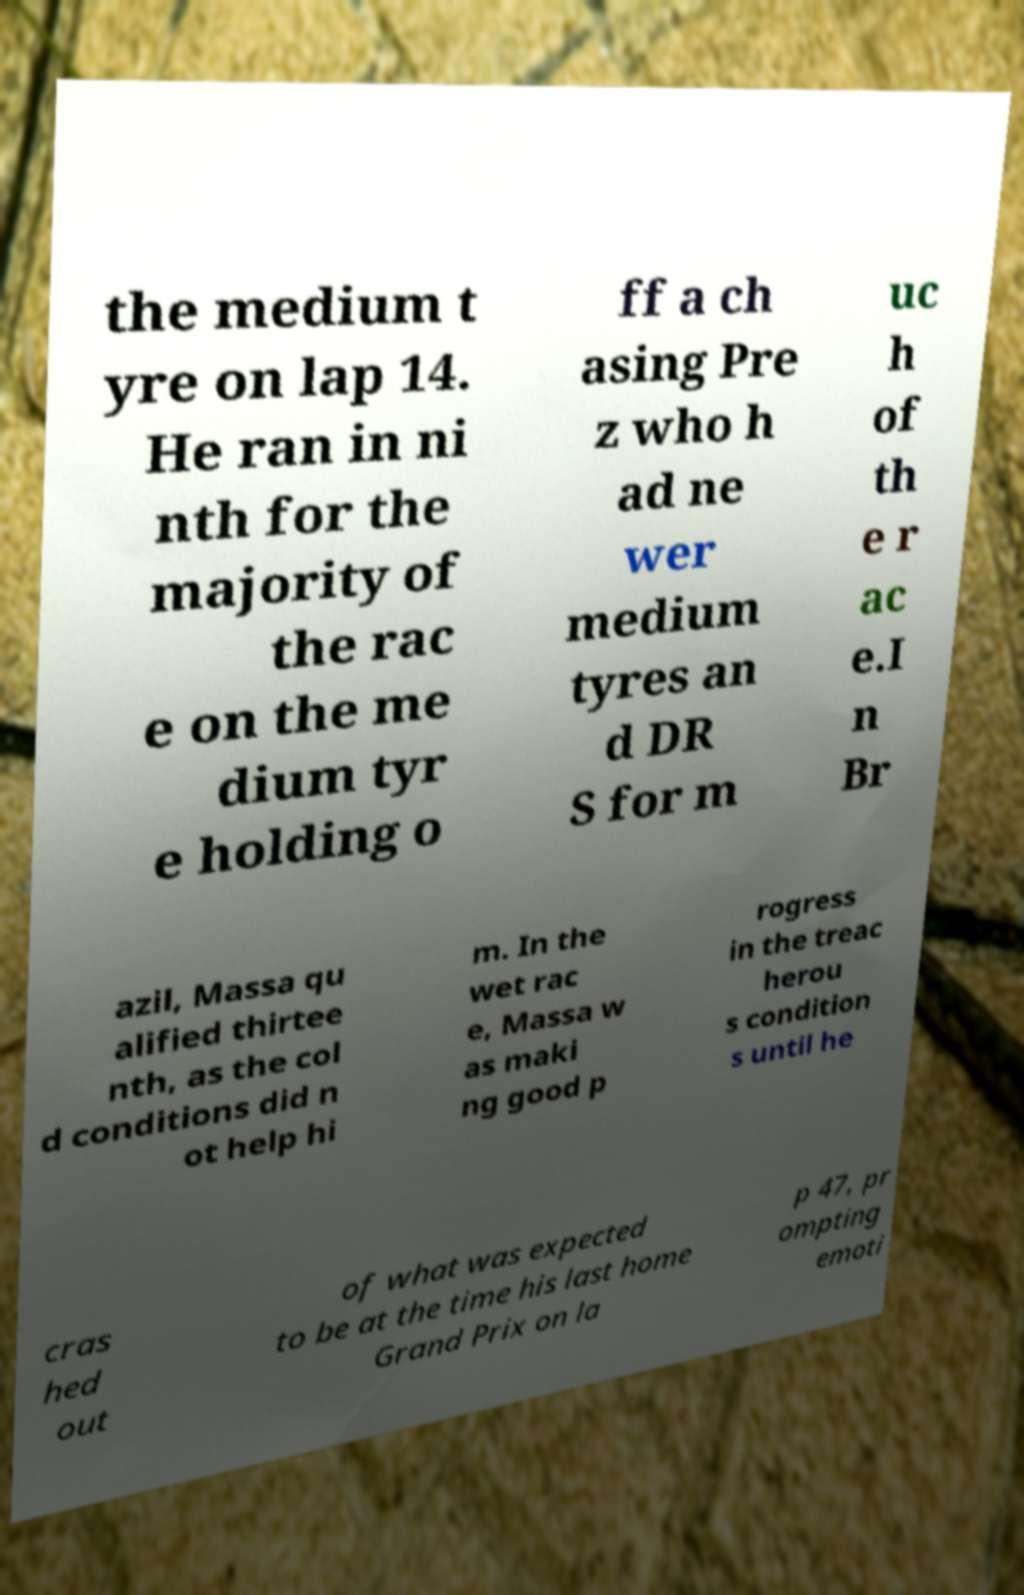I need the written content from this picture converted into text. Can you do that? the medium t yre on lap 14. He ran in ni nth for the majority of the rac e on the me dium tyr e holding o ff a ch asing Pre z who h ad ne wer medium tyres an d DR S for m uc h of th e r ac e.I n Br azil, Massa qu alified thirtee nth, as the col d conditions did n ot help hi m. In the wet rac e, Massa w as maki ng good p rogress in the treac herou s condition s until he cras hed out of what was expected to be at the time his last home Grand Prix on la p 47, pr ompting emoti 